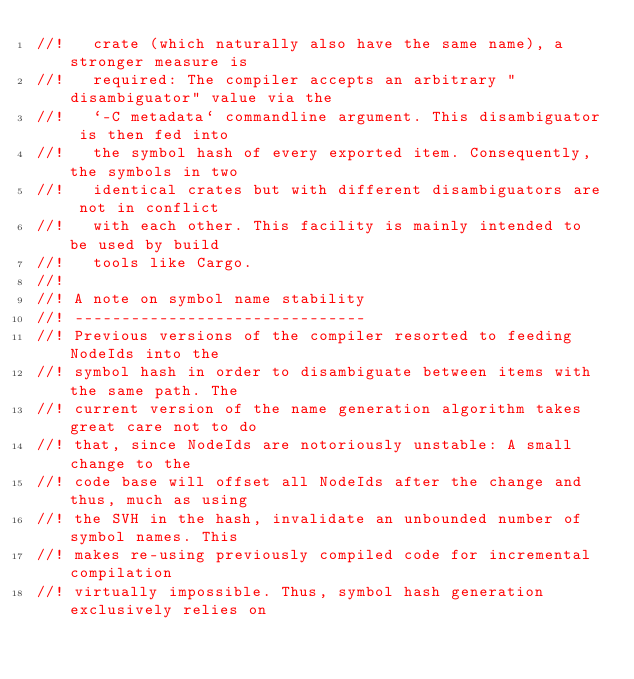Convert code to text. <code><loc_0><loc_0><loc_500><loc_500><_Rust_>//!   crate (which naturally also have the same name), a stronger measure is
//!   required: The compiler accepts an arbitrary "disambiguator" value via the
//!   `-C metadata` commandline argument. This disambiguator is then fed into
//!   the symbol hash of every exported item. Consequently, the symbols in two
//!   identical crates but with different disambiguators are not in conflict
//!   with each other. This facility is mainly intended to be used by build
//!   tools like Cargo.
//!
//! A note on symbol name stability
//! -------------------------------
//! Previous versions of the compiler resorted to feeding NodeIds into the
//! symbol hash in order to disambiguate between items with the same path. The
//! current version of the name generation algorithm takes great care not to do
//! that, since NodeIds are notoriously unstable: A small change to the
//! code base will offset all NodeIds after the change and thus, much as using
//! the SVH in the hash, invalidate an unbounded number of symbol names. This
//! makes re-using previously compiled code for incremental compilation
//! virtually impossible. Thus, symbol hash generation exclusively relies on</code> 